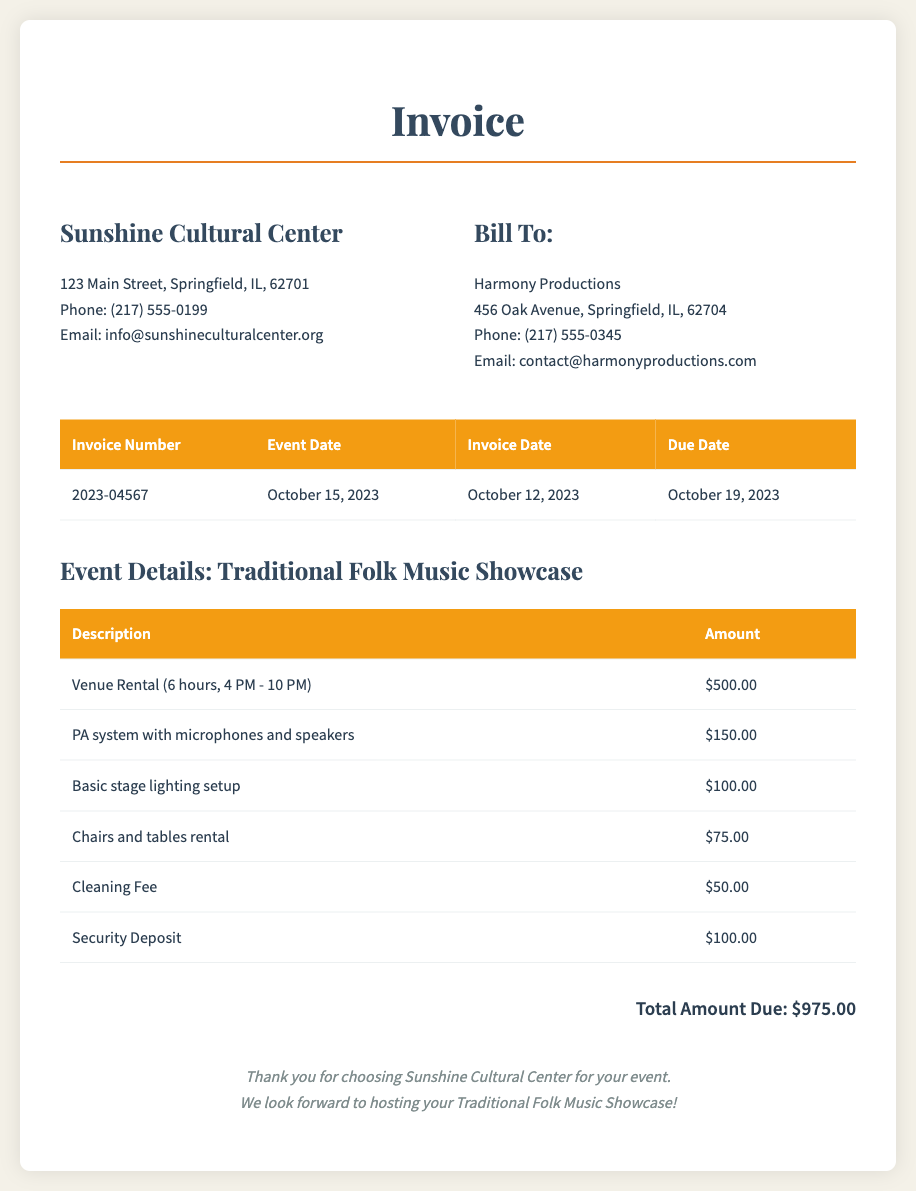What is the name of the cultural center? The name of the cultural center is found in the header section of the document.
Answer: Sunshine Cultural Center What is the event date? The event date is explicitly listed in the invoice details table.
Answer: October 15, 2023 What is the total amount due? The total amount due is stated at the end of the invoice, summarizing all charges.
Answer: $975.00 How many hours was the venue rented for? The hours of rental are specified in the event details section of the document.
Answer: 6 hours What is the amount charged for the PA system? The amount for the PA system is outlined in the event details table alongside other charges.
Answer: $150.00 What is the security deposit amount? The security deposit is included in the breakdown of charges, providing a specific value.
Answer: $100.00 What time did the event start? The start time of the event is mentioned in the venue rental description.
Answer: 4 PM What is the cleaning fee? The cleaning fee is listed as one of the additional charges in the invoice.
Answer: $50.00 What is the invoice number? The invoice number is found in the table that summarizes invoice details.
Answer: 2023-04567 